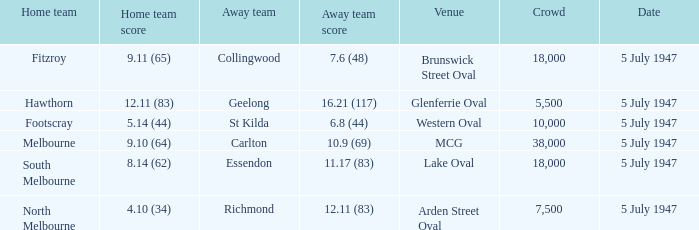Who was the away team when North Melbourne was the home team? Richmond. 